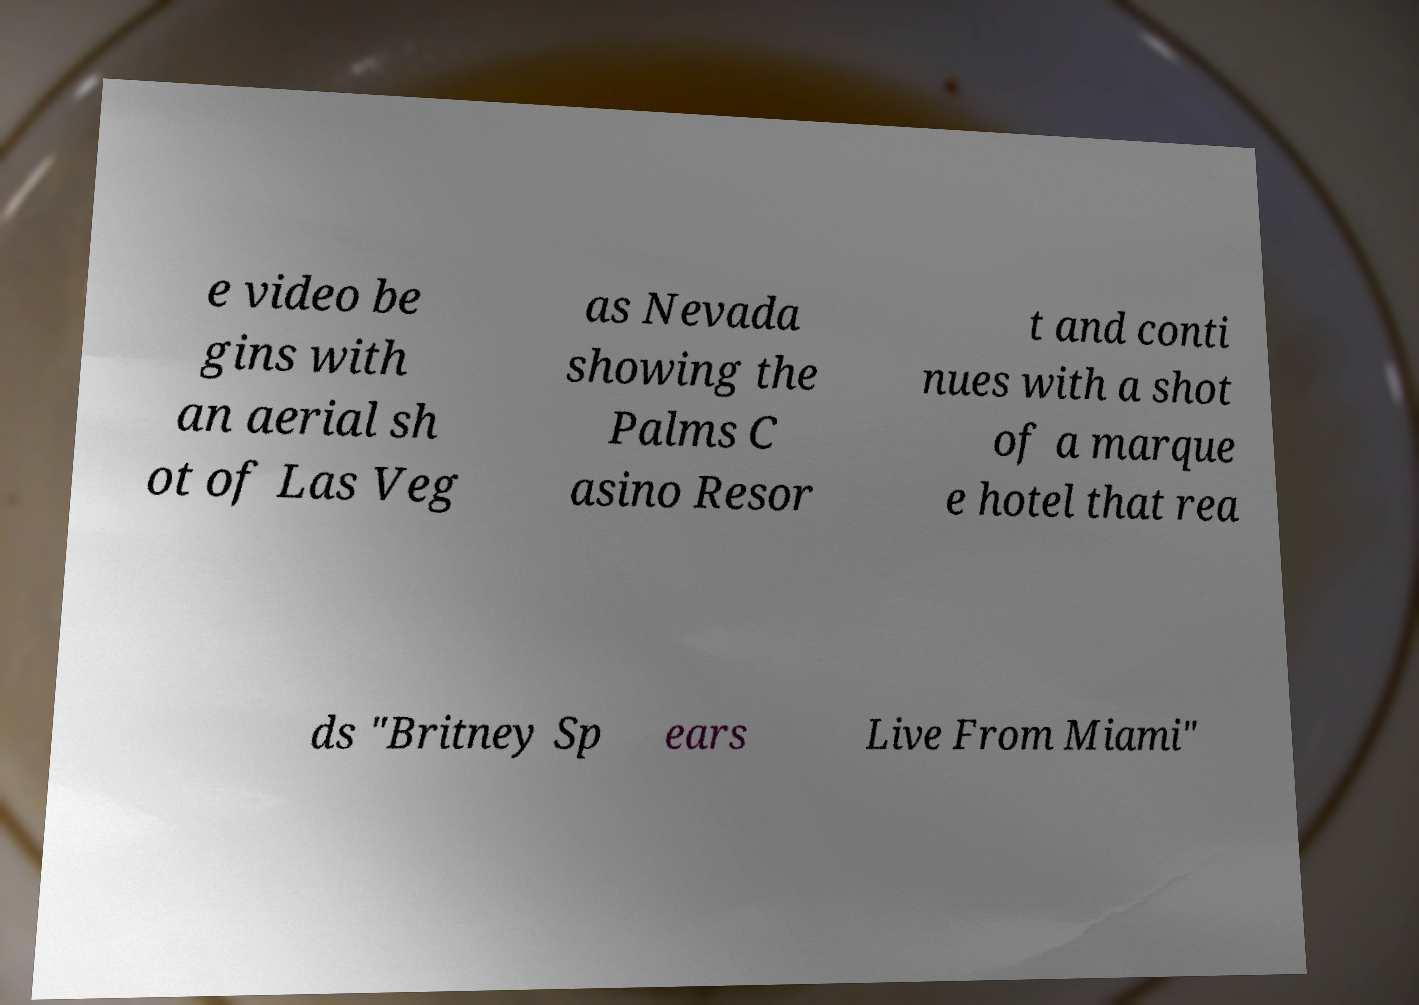I need the written content from this picture converted into text. Can you do that? e video be gins with an aerial sh ot of Las Veg as Nevada showing the Palms C asino Resor t and conti nues with a shot of a marque e hotel that rea ds "Britney Sp ears Live From Miami" 